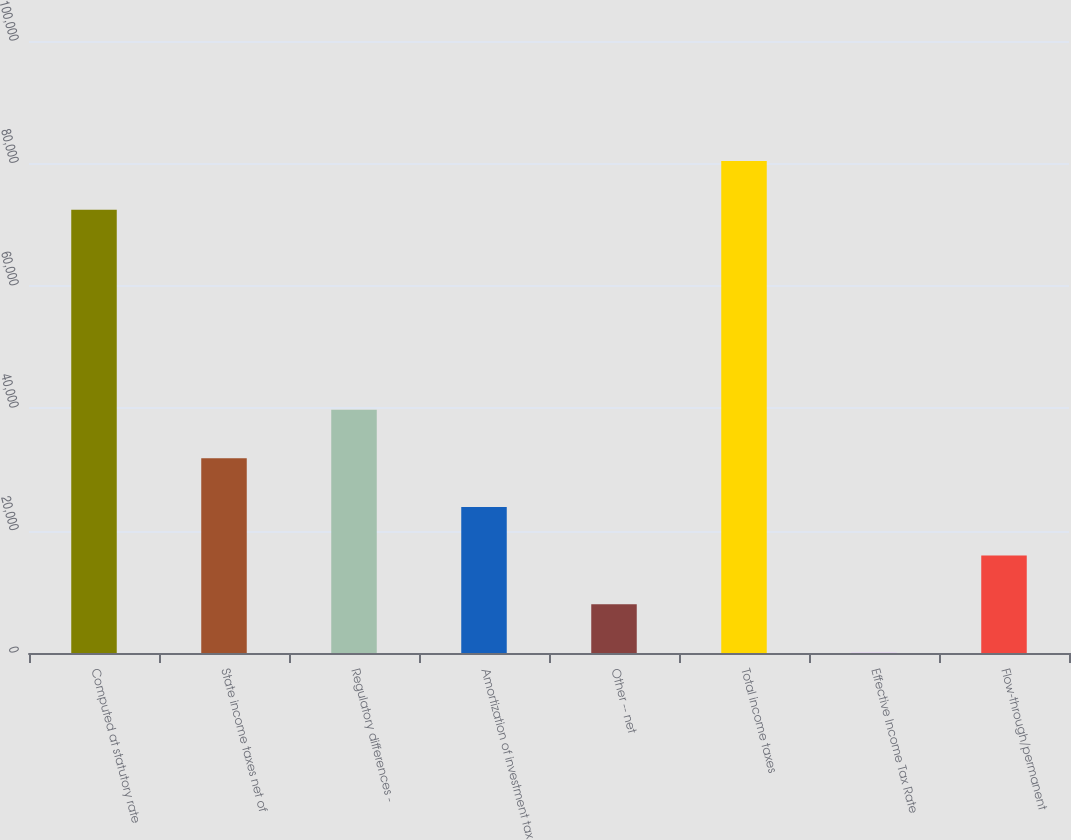<chart> <loc_0><loc_0><loc_500><loc_500><bar_chart><fcel>Computed at statutory rate<fcel>State income taxes net of<fcel>Regulatory differences -<fcel>Amortization of investment tax<fcel>Other -- net<fcel>Total income taxes<fcel>Effective Income Tax Rate<fcel>Flow-through/permanent<nl><fcel>72440<fcel>31813<fcel>39756.7<fcel>23869.4<fcel>7982.06<fcel>80383.7<fcel>38.4<fcel>15925.7<nl></chart> 